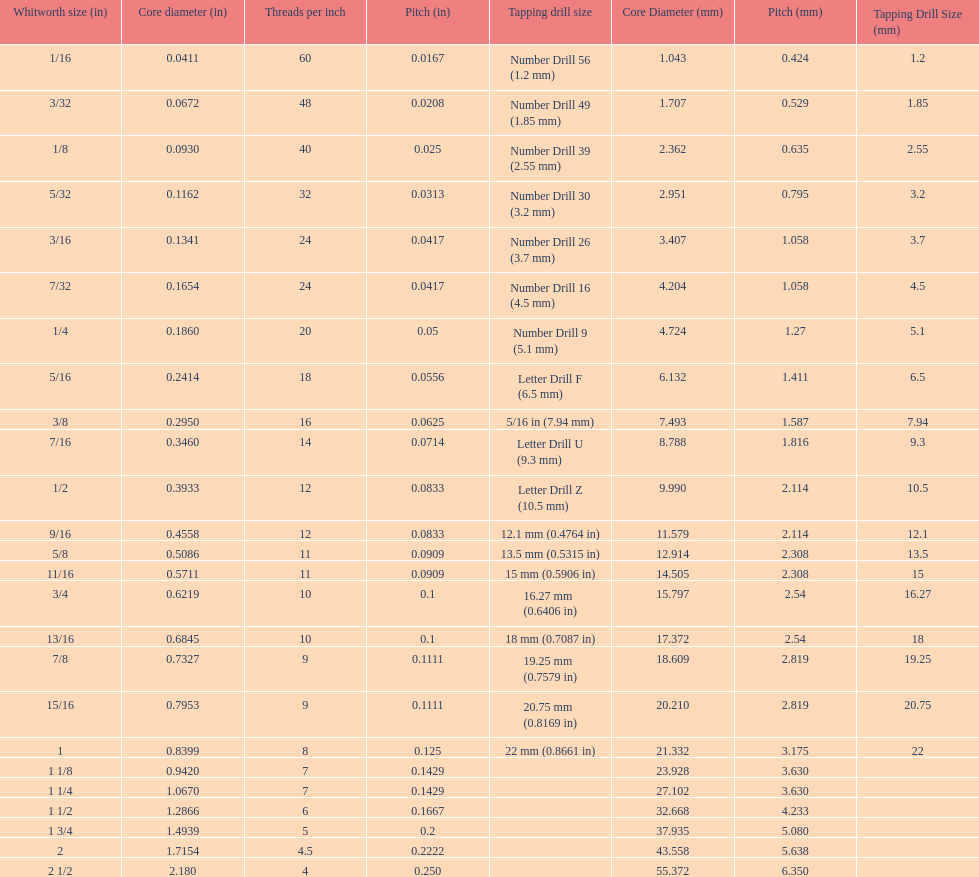Which whitworth size has the same number of threads per inch as 3/16? 7/32. 